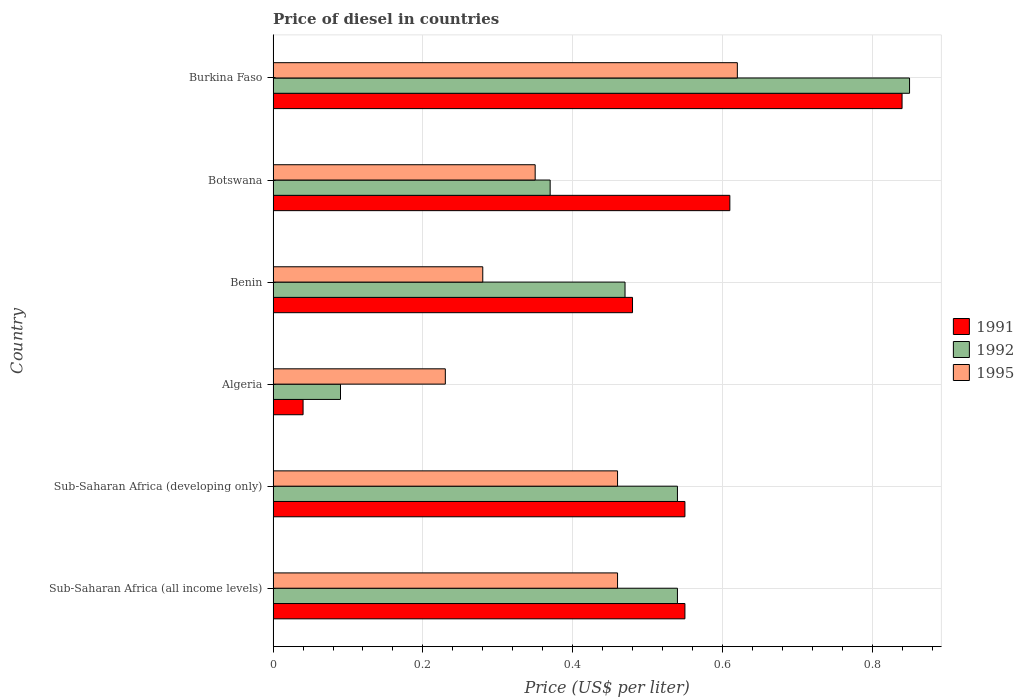How many groups of bars are there?
Your answer should be compact. 6. How many bars are there on the 6th tick from the top?
Your response must be concise. 3. How many bars are there on the 3rd tick from the bottom?
Your response must be concise. 3. What is the label of the 6th group of bars from the top?
Your answer should be compact. Sub-Saharan Africa (all income levels). In how many cases, is the number of bars for a given country not equal to the number of legend labels?
Ensure brevity in your answer.  0. What is the price of diesel in 1991 in Sub-Saharan Africa (all income levels)?
Offer a very short reply. 0.55. Across all countries, what is the maximum price of diesel in 1995?
Ensure brevity in your answer.  0.62. Across all countries, what is the minimum price of diesel in 1991?
Your answer should be very brief. 0.04. In which country was the price of diesel in 1991 maximum?
Provide a succinct answer. Burkina Faso. In which country was the price of diesel in 1991 minimum?
Provide a succinct answer. Algeria. What is the total price of diesel in 1992 in the graph?
Ensure brevity in your answer.  2.86. What is the difference between the price of diesel in 1991 in Benin and that in Botswana?
Your response must be concise. -0.13. What is the difference between the price of diesel in 1995 in Sub-Saharan Africa (all income levels) and the price of diesel in 1991 in Benin?
Your response must be concise. -0.02. What is the average price of diesel in 1995 per country?
Make the answer very short. 0.4. What is the difference between the price of diesel in 1995 and price of diesel in 1992 in Sub-Saharan Africa (all income levels)?
Offer a terse response. -0.08. What is the ratio of the price of diesel in 1991 in Burkina Faso to that in Sub-Saharan Africa (developing only)?
Ensure brevity in your answer.  1.53. Is the difference between the price of diesel in 1995 in Algeria and Botswana greater than the difference between the price of diesel in 1992 in Algeria and Botswana?
Ensure brevity in your answer.  Yes. What is the difference between the highest and the second highest price of diesel in 1991?
Offer a terse response. 0.23. What is the difference between the highest and the lowest price of diesel in 1991?
Offer a terse response. 0.8. In how many countries, is the price of diesel in 1995 greater than the average price of diesel in 1995 taken over all countries?
Make the answer very short. 3. What does the 2nd bar from the top in Benin represents?
Your response must be concise. 1992. What does the 3rd bar from the bottom in Sub-Saharan Africa (all income levels) represents?
Make the answer very short. 1995. How many bars are there?
Offer a terse response. 18. How many countries are there in the graph?
Your response must be concise. 6. What is the difference between two consecutive major ticks on the X-axis?
Keep it short and to the point. 0.2. Does the graph contain any zero values?
Provide a short and direct response. No. How are the legend labels stacked?
Your answer should be compact. Vertical. What is the title of the graph?
Ensure brevity in your answer.  Price of diesel in countries. Does "1998" appear as one of the legend labels in the graph?
Provide a succinct answer. No. What is the label or title of the X-axis?
Provide a succinct answer. Price (US$ per liter). What is the Price (US$ per liter) in 1991 in Sub-Saharan Africa (all income levels)?
Your response must be concise. 0.55. What is the Price (US$ per liter) in 1992 in Sub-Saharan Africa (all income levels)?
Offer a terse response. 0.54. What is the Price (US$ per liter) in 1995 in Sub-Saharan Africa (all income levels)?
Keep it short and to the point. 0.46. What is the Price (US$ per liter) in 1991 in Sub-Saharan Africa (developing only)?
Make the answer very short. 0.55. What is the Price (US$ per liter) of 1992 in Sub-Saharan Africa (developing only)?
Provide a succinct answer. 0.54. What is the Price (US$ per liter) in 1995 in Sub-Saharan Africa (developing only)?
Make the answer very short. 0.46. What is the Price (US$ per liter) of 1992 in Algeria?
Offer a terse response. 0.09. What is the Price (US$ per liter) in 1995 in Algeria?
Provide a short and direct response. 0.23. What is the Price (US$ per liter) in 1991 in Benin?
Offer a very short reply. 0.48. What is the Price (US$ per liter) of 1992 in Benin?
Your response must be concise. 0.47. What is the Price (US$ per liter) of 1995 in Benin?
Offer a very short reply. 0.28. What is the Price (US$ per liter) in 1991 in Botswana?
Provide a succinct answer. 0.61. What is the Price (US$ per liter) of 1992 in Botswana?
Provide a short and direct response. 0.37. What is the Price (US$ per liter) of 1991 in Burkina Faso?
Offer a terse response. 0.84. What is the Price (US$ per liter) in 1995 in Burkina Faso?
Give a very brief answer. 0.62. Across all countries, what is the maximum Price (US$ per liter) of 1991?
Offer a terse response. 0.84. Across all countries, what is the maximum Price (US$ per liter) in 1992?
Keep it short and to the point. 0.85. Across all countries, what is the maximum Price (US$ per liter) in 1995?
Keep it short and to the point. 0.62. Across all countries, what is the minimum Price (US$ per liter) in 1992?
Give a very brief answer. 0.09. Across all countries, what is the minimum Price (US$ per liter) of 1995?
Ensure brevity in your answer.  0.23. What is the total Price (US$ per liter) in 1991 in the graph?
Keep it short and to the point. 3.07. What is the total Price (US$ per liter) of 1992 in the graph?
Provide a succinct answer. 2.86. What is the difference between the Price (US$ per liter) of 1991 in Sub-Saharan Africa (all income levels) and that in Sub-Saharan Africa (developing only)?
Your answer should be compact. 0. What is the difference between the Price (US$ per liter) of 1995 in Sub-Saharan Africa (all income levels) and that in Sub-Saharan Africa (developing only)?
Give a very brief answer. 0. What is the difference between the Price (US$ per liter) of 1991 in Sub-Saharan Africa (all income levels) and that in Algeria?
Provide a short and direct response. 0.51. What is the difference between the Price (US$ per liter) in 1992 in Sub-Saharan Africa (all income levels) and that in Algeria?
Give a very brief answer. 0.45. What is the difference between the Price (US$ per liter) in 1995 in Sub-Saharan Africa (all income levels) and that in Algeria?
Your answer should be very brief. 0.23. What is the difference between the Price (US$ per liter) of 1991 in Sub-Saharan Africa (all income levels) and that in Benin?
Your answer should be compact. 0.07. What is the difference between the Price (US$ per liter) of 1992 in Sub-Saharan Africa (all income levels) and that in Benin?
Offer a very short reply. 0.07. What is the difference between the Price (US$ per liter) in 1995 in Sub-Saharan Africa (all income levels) and that in Benin?
Offer a very short reply. 0.18. What is the difference between the Price (US$ per liter) of 1991 in Sub-Saharan Africa (all income levels) and that in Botswana?
Your answer should be compact. -0.06. What is the difference between the Price (US$ per liter) of 1992 in Sub-Saharan Africa (all income levels) and that in Botswana?
Your answer should be compact. 0.17. What is the difference between the Price (US$ per liter) of 1995 in Sub-Saharan Africa (all income levels) and that in Botswana?
Ensure brevity in your answer.  0.11. What is the difference between the Price (US$ per liter) of 1991 in Sub-Saharan Africa (all income levels) and that in Burkina Faso?
Offer a terse response. -0.29. What is the difference between the Price (US$ per liter) in 1992 in Sub-Saharan Africa (all income levels) and that in Burkina Faso?
Your response must be concise. -0.31. What is the difference between the Price (US$ per liter) of 1995 in Sub-Saharan Africa (all income levels) and that in Burkina Faso?
Offer a very short reply. -0.16. What is the difference between the Price (US$ per liter) of 1991 in Sub-Saharan Africa (developing only) and that in Algeria?
Give a very brief answer. 0.51. What is the difference between the Price (US$ per liter) of 1992 in Sub-Saharan Africa (developing only) and that in Algeria?
Provide a succinct answer. 0.45. What is the difference between the Price (US$ per liter) in 1995 in Sub-Saharan Africa (developing only) and that in Algeria?
Offer a very short reply. 0.23. What is the difference between the Price (US$ per liter) of 1991 in Sub-Saharan Africa (developing only) and that in Benin?
Offer a terse response. 0.07. What is the difference between the Price (US$ per liter) of 1992 in Sub-Saharan Africa (developing only) and that in Benin?
Keep it short and to the point. 0.07. What is the difference between the Price (US$ per liter) in 1995 in Sub-Saharan Africa (developing only) and that in Benin?
Provide a succinct answer. 0.18. What is the difference between the Price (US$ per liter) in 1991 in Sub-Saharan Africa (developing only) and that in Botswana?
Your response must be concise. -0.06. What is the difference between the Price (US$ per liter) in 1992 in Sub-Saharan Africa (developing only) and that in Botswana?
Offer a very short reply. 0.17. What is the difference between the Price (US$ per liter) in 1995 in Sub-Saharan Africa (developing only) and that in Botswana?
Give a very brief answer. 0.11. What is the difference between the Price (US$ per liter) of 1991 in Sub-Saharan Africa (developing only) and that in Burkina Faso?
Keep it short and to the point. -0.29. What is the difference between the Price (US$ per liter) in 1992 in Sub-Saharan Africa (developing only) and that in Burkina Faso?
Your answer should be very brief. -0.31. What is the difference between the Price (US$ per liter) of 1995 in Sub-Saharan Africa (developing only) and that in Burkina Faso?
Offer a very short reply. -0.16. What is the difference between the Price (US$ per liter) of 1991 in Algeria and that in Benin?
Your response must be concise. -0.44. What is the difference between the Price (US$ per liter) of 1992 in Algeria and that in Benin?
Your answer should be compact. -0.38. What is the difference between the Price (US$ per liter) of 1991 in Algeria and that in Botswana?
Keep it short and to the point. -0.57. What is the difference between the Price (US$ per liter) in 1992 in Algeria and that in Botswana?
Provide a short and direct response. -0.28. What is the difference between the Price (US$ per liter) in 1995 in Algeria and that in Botswana?
Your answer should be compact. -0.12. What is the difference between the Price (US$ per liter) of 1992 in Algeria and that in Burkina Faso?
Make the answer very short. -0.76. What is the difference between the Price (US$ per liter) of 1995 in Algeria and that in Burkina Faso?
Ensure brevity in your answer.  -0.39. What is the difference between the Price (US$ per liter) of 1991 in Benin and that in Botswana?
Give a very brief answer. -0.13. What is the difference between the Price (US$ per liter) in 1995 in Benin and that in Botswana?
Keep it short and to the point. -0.07. What is the difference between the Price (US$ per liter) of 1991 in Benin and that in Burkina Faso?
Give a very brief answer. -0.36. What is the difference between the Price (US$ per liter) of 1992 in Benin and that in Burkina Faso?
Your response must be concise. -0.38. What is the difference between the Price (US$ per liter) of 1995 in Benin and that in Burkina Faso?
Your answer should be very brief. -0.34. What is the difference between the Price (US$ per liter) of 1991 in Botswana and that in Burkina Faso?
Provide a short and direct response. -0.23. What is the difference between the Price (US$ per liter) in 1992 in Botswana and that in Burkina Faso?
Ensure brevity in your answer.  -0.48. What is the difference between the Price (US$ per liter) of 1995 in Botswana and that in Burkina Faso?
Give a very brief answer. -0.27. What is the difference between the Price (US$ per liter) in 1991 in Sub-Saharan Africa (all income levels) and the Price (US$ per liter) in 1995 in Sub-Saharan Africa (developing only)?
Provide a succinct answer. 0.09. What is the difference between the Price (US$ per liter) of 1992 in Sub-Saharan Africa (all income levels) and the Price (US$ per liter) of 1995 in Sub-Saharan Africa (developing only)?
Your answer should be compact. 0.08. What is the difference between the Price (US$ per liter) in 1991 in Sub-Saharan Africa (all income levels) and the Price (US$ per liter) in 1992 in Algeria?
Make the answer very short. 0.46. What is the difference between the Price (US$ per liter) in 1991 in Sub-Saharan Africa (all income levels) and the Price (US$ per liter) in 1995 in Algeria?
Offer a terse response. 0.32. What is the difference between the Price (US$ per liter) of 1992 in Sub-Saharan Africa (all income levels) and the Price (US$ per liter) of 1995 in Algeria?
Provide a succinct answer. 0.31. What is the difference between the Price (US$ per liter) in 1991 in Sub-Saharan Africa (all income levels) and the Price (US$ per liter) in 1995 in Benin?
Offer a terse response. 0.27. What is the difference between the Price (US$ per liter) of 1992 in Sub-Saharan Africa (all income levels) and the Price (US$ per liter) of 1995 in Benin?
Your answer should be very brief. 0.26. What is the difference between the Price (US$ per liter) in 1991 in Sub-Saharan Africa (all income levels) and the Price (US$ per liter) in 1992 in Botswana?
Offer a terse response. 0.18. What is the difference between the Price (US$ per liter) in 1992 in Sub-Saharan Africa (all income levels) and the Price (US$ per liter) in 1995 in Botswana?
Ensure brevity in your answer.  0.19. What is the difference between the Price (US$ per liter) in 1991 in Sub-Saharan Africa (all income levels) and the Price (US$ per liter) in 1992 in Burkina Faso?
Your answer should be compact. -0.3. What is the difference between the Price (US$ per liter) in 1991 in Sub-Saharan Africa (all income levels) and the Price (US$ per liter) in 1995 in Burkina Faso?
Your response must be concise. -0.07. What is the difference between the Price (US$ per liter) in 1992 in Sub-Saharan Africa (all income levels) and the Price (US$ per liter) in 1995 in Burkina Faso?
Give a very brief answer. -0.08. What is the difference between the Price (US$ per liter) of 1991 in Sub-Saharan Africa (developing only) and the Price (US$ per liter) of 1992 in Algeria?
Your answer should be compact. 0.46. What is the difference between the Price (US$ per liter) in 1991 in Sub-Saharan Africa (developing only) and the Price (US$ per liter) in 1995 in Algeria?
Your answer should be very brief. 0.32. What is the difference between the Price (US$ per liter) in 1992 in Sub-Saharan Africa (developing only) and the Price (US$ per liter) in 1995 in Algeria?
Offer a very short reply. 0.31. What is the difference between the Price (US$ per liter) of 1991 in Sub-Saharan Africa (developing only) and the Price (US$ per liter) of 1995 in Benin?
Offer a very short reply. 0.27. What is the difference between the Price (US$ per liter) of 1992 in Sub-Saharan Africa (developing only) and the Price (US$ per liter) of 1995 in Benin?
Give a very brief answer. 0.26. What is the difference between the Price (US$ per liter) of 1991 in Sub-Saharan Africa (developing only) and the Price (US$ per liter) of 1992 in Botswana?
Provide a succinct answer. 0.18. What is the difference between the Price (US$ per liter) in 1992 in Sub-Saharan Africa (developing only) and the Price (US$ per liter) in 1995 in Botswana?
Keep it short and to the point. 0.19. What is the difference between the Price (US$ per liter) in 1991 in Sub-Saharan Africa (developing only) and the Price (US$ per liter) in 1995 in Burkina Faso?
Your answer should be very brief. -0.07. What is the difference between the Price (US$ per liter) in 1992 in Sub-Saharan Africa (developing only) and the Price (US$ per liter) in 1995 in Burkina Faso?
Your response must be concise. -0.08. What is the difference between the Price (US$ per liter) of 1991 in Algeria and the Price (US$ per liter) of 1992 in Benin?
Your answer should be very brief. -0.43. What is the difference between the Price (US$ per liter) in 1991 in Algeria and the Price (US$ per liter) in 1995 in Benin?
Ensure brevity in your answer.  -0.24. What is the difference between the Price (US$ per liter) in 1992 in Algeria and the Price (US$ per liter) in 1995 in Benin?
Your response must be concise. -0.19. What is the difference between the Price (US$ per liter) in 1991 in Algeria and the Price (US$ per liter) in 1992 in Botswana?
Provide a short and direct response. -0.33. What is the difference between the Price (US$ per liter) of 1991 in Algeria and the Price (US$ per liter) of 1995 in Botswana?
Keep it short and to the point. -0.31. What is the difference between the Price (US$ per liter) of 1992 in Algeria and the Price (US$ per liter) of 1995 in Botswana?
Provide a succinct answer. -0.26. What is the difference between the Price (US$ per liter) in 1991 in Algeria and the Price (US$ per liter) in 1992 in Burkina Faso?
Provide a short and direct response. -0.81. What is the difference between the Price (US$ per liter) of 1991 in Algeria and the Price (US$ per liter) of 1995 in Burkina Faso?
Make the answer very short. -0.58. What is the difference between the Price (US$ per liter) of 1992 in Algeria and the Price (US$ per liter) of 1995 in Burkina Faso?
Make the answer very short. -0.53. What is the difference between the Price (US$ per liter) in 1991 in Benin and the Price (US$ per liter) in 1992 in Botswana?
Give a very brief answer. 0.11. What is the difference between the Price (US$ per liter) in 1991 in Benin and the Price (US$ per liter) in 1995 in Botswana?
Your response must be concise. 0.13. What is the difference between the Price (US$ per liter) of 1992 in Benin and the Price (US$ per liter) of 1995 in Botswana?
Make the answer very short. 0.12. What is the difference between the Price (US$ per liter) in 1991 in Benin and the Price (US$ per liter) in 1992 in Burkina Faso?
Give a very brief answer. -0.37. What is the difference between the Price (US$ per liter) of 1991 in Benin and the Price (US$ per liter) of 1995 in Burkina Faso?
Make the answer very short. -0.14. What is the difference between the Price (US$ per liter) in 1991 in Botswana and the Price (US$ per liter) in 1992 in Burkina Faso?
Your answer should be compact. -0.24. What is the difference between the Price (US$ per liter) of 1991 in Botswana and the Price (US$ per liter) of 1995 in Burkina Faso?
Offer a terse response. -0.01. What is the average Price (US$ per liter) of 1991 per country?
Your response must be concise. 0.51. What is the average Price (US$ per liter) in 1992 per country?
Keep it short and to the point. 0.48. What is the average Price (US$ per liter) of 1995 per country?
Keep it short and to the point. 0.4. What is the difference between the Price (US$ per liter) of 1991 and Price (US$ per liter) of 1992 in Sub-Saharan Africa (all income levels)?
Offer a very short reply. 0.01. What is the difference between the Price (US$ per liter) of 1991 and Price (US$ per liter) of 1995 in Sub-Saharan Africa (all income levels)?
Give a very brief answer. 0.09. What is the difference between the Price (US$ per liter) of 1992 and Price (US$ per liter) of 1995 in Sub-Saharan Africa (all income levels)?
Your response must be concise. 0.08. What is the difference between the Price (US$ per liter) in 1991 and Price (US$ per liter) in 1992 in Sub-Saharan Africa (developing only)?
Your answer should be compact. 0.01. What is the difference between the Price (US$ per liter) of 1991 and Price (US$ per liter) of 1995 in Sub-Saharan Africa (developing only)?
Your response must be concise. 0.09. What is the difference between the Price (US$ per liter) in 1992 and Price (US$ per liter) in 1995 in Sub-Saharan Africa (developing only)?
Your response must be concise. 0.08. What is the difference between the Price (US$ per liter) of 1991 and Price (US$ per liter) of 1992 in Algeria?
Make the answer very short. -0.05. What is the difference between the Price (US$ per liter) of 1991 and Price (US$ per liter) of 1995 in Algeria?
Give a very brief answer. -0.19. What is the difference between the Price (US$ per liter) in 1992 and Price (US$ per liter) in 1995 in Algeria?
Your answer should be very brief. -0.14. What is the difference between the Price (US$ per liter) of 1992 and Price (US$ per liter) of 1995 in Benin?
Provide a succinct answer. 0.19. What is the difference between the Price (US$ per liter) in 1991 and Price (US$ per liter) in 1992 in Botswana?
Provide a short and direct response. 0.24. What is the difference between the Price (US$ per liter) of 1991 and Price (US$ per liter) of 1995 in Botswana?
Make the answer very short. 0.26. What is the difference between the Price (US$ per liter) of 1992 and Price (US$ per liter) of 1995 in Botswana?
Provide a short and direct response. 0.02. What is the difference between the Price (US$ per liter) of 1991 and Price (US$ per liter) of 1992 in Burkina Faso?
Your answer should be very brief. -0.01. What is the difference between the Price (US$ per liter) of 1991 and Price (US$ per liter) of 1995 in Burkina Faso?
Give a very brief answer. 0.22. What is the difference between the Price (US$ per liter) of 1992 and Price (US$ per liter) of 1995 in Burkina Faso?
Provide a short and direct response. 0.23. What is the ratio of the Price (US$ per liter) in 1991 in Sub-Saharan Africa (all income levels) to that in Sub-Saharan Africa (developing only)?
Provide a short and direct response. 1. What is the ratio of the Price (US$ per liter) in 1992 in Sub-Saharan Africa (all income levels) to that in Sub-Saharan Africa (developing only)?
Your answer should be compact. 1. What is the ratio of the Price (US$ per liter) of 1995 in Sub-Saharan Africa (all income levels) to that in Sub-Saharan Africa (developing only)?
Ensure brevity in your answer.  1. What is the ratio of the Price (US$ per liter) of 1991 in Sub-Saharan Africa (all income levels) to that in Algeria?
Provide a short and direct response. 13.75. What is the ratio of the Price (US$ per liter) of 1992 in Sub-Saharan Africa (all income levels) to that in Algeria?
Provide a succinct answer. 6. What is the ratio of the Price (US$ per liter) in 1995 in Sub-Saharan Africa (all income levels) to that in Algeria?
Give a very brief answer. 2. What is the ratio of the Price (US$ per liter) of 1991 in Sub-Saharan Africa (all income levels) to that in Benin?
Keep it short and to the point. 1.15. What is the ratio of the Price (US$ per liter) of 1992 in Sub-Saharan Africa (all income levels) to that in Benin?
Your answer should be very brief. 1.15. What is the ratio of the Price (US$ per liter) in 1995 in Sub-Saharan Africa (all income levels) to that in Benin?
Offer a terse response. 1.64. What is the ratio of the Price (US$ per liter) of 1991 in Sub-Saharan Africa (all income levels) to that in Botswana?
Provide a succinct answer. 0.9. What is the ratio of the Price (US$ per liter) of 1992 in Sub-Saharan Africa (all income levels) to that in Botswana?
Provide a short and direct response. 1.46. What is the ratio of the Price (US$ per liter) of 1995 in Sub-Saharan Africa (all income levels) to that in Botswana?
Your answer should be compact. 1.31. What is the ratio of the Price (US$ per liter) of 1991 in Sub-Saharan Africa (all income levels) to that in Burkina Faso?
Your answer should be very brief. 0.65. What is the ratio of the Price (US$ per liter) of 1992 in Sub-Saharan Africa (all income levels) to that in Burkina Faso?
Make the answer very short. 0.64. What is the ratio of the Price (US$ per liter) in 1995 in Sub-Saharan Africa (all income levels) to that in Burkina Faso?
Offer a terse response. 0.74. What is the ratio of the Price (US$ per liter) of 1991 in Sub-Saharan Africa (developing only) to that in Algeria?
Keep it short and to the point. 13.75. What is the ratio of the Price (US$ per liter) in 1992 in Sub-Saharan Africa (developing only) to that in Algeria?
Ensure brevity in your answer.  6. What is the ratio of the Price (US$ per liter) of 1991 in Sub-Saharan Africa (developing only) to that in Benin?
Provide a succinct answer. 1.15. What is the ratio of the Price (US$ per liter) in 1992 in Sub-Saharan Africa (developing only) to that in Benin?
Make the answer very short. 1.15. What is the ratio of the Price (US$ per liter) in 1995 in Sub-Saharan Africa (developing only) to that in Benin?
Make the answer very short. 1.64. What is the ratio of the Price (US$ per liter) of 1991 in Sub-Saharan Africa (developing only) to that in Botswana?
Provide a short and direct response. 0.9. What is the ratio of the Price (US$ per liter) in 1992 in Sub-Saharan Africa (developing only) to that in Botswana?
Provide a succinct answer. 1.46. What is the ratio of the Price (US$ per liter) in 1995 in Sub-Saharan Africa (developing only) to that in Botswana?
Provide a succinct answer. 1.31. What is the ratio of the Price (US$ per liter) of 1991 in Sub-Saharan Africa (developing only) to that in Burkina Faso?
Offer a terse response. 0.65. What is the ratio of the Price (US$ per liter) in 1992 in Sub-Saharan Africa (developing only) to that in Burkina Faso?
Offer a terse response. 0.64. What is the ratio of the Price (US$ per liter) of 1995 in Sub-Saharan Africa (developing only) to that in Burkina Faso?
Provide a succinct answer. 0.74. What is the ratio of the Price (US$ per liter) of 1991 in Algeria to that in Benin?
Your response must be concise. 0.08. What is the ratio of the Price (US$ per liter) in 1992 in Algeria to that in Benin?
Offer a terse response. 0.19. What is the ratio of the Price (US$ per liter) in 1995 in Algeria to that in Benin?
Offer a terse response. 0.82. What is the ratio of the Price (US$ per liter) in 1991 in Algeria to that in Botswana?
Your response must be concise. 0.07. What is the ratio of the Price (US$ per liter) of 1992 in Algeria to that in Botswana?
Give a very brief answer. 0.24. What is the ratio of the Price (US$ per liter) in 1995 in Algeria to that in Botswana?
Keep it short and to the point. 0.66. What is the ratio of the Price (US$ per liter) in 1991 in Algeria to that in Burkina Faso?
Give a very brief answer. 0.05. What is the ratio of the Price (US$ per liter) of 1992 in Algeria to that in Burkina Faso?
Your answer should be compact. 0.11. What is the ratio of the Price (US$ per liter) of 1995 in Algeria to that in Burkina Faso?
Make the answer very short. 0.37. What is the ratio of the Price (US$ per liter) in 1991 in Benin to that in Botswana?
Provide a short and direct response. 0.79. What is the ratio of the Price (US$ per liter) of 1992 in Benin to that in Botswana?
Keep it short and to the point. 1.27. What is the ratio of the Price (US$ per liter) of 1991 in Benin to that in Burkina Faso?
Keep it short and to the point. 0.57. What is the ratio of the Price (US$ per liter) in 1992 in Benin to that in Burkina Faso?
Keep it short and to the point. 0.55. What is the ratio of the Price (US$ per liter) in 1995 in Benin to that in Burkina Faso?
Ensure brevity in your answer.  0.45. What is the ratio of the Price (US$ per liter) of 1991 in Botswana to that in Burkina Faso?
Offer a terse response. 0.73. What is the ratio of the Price (US$ per liter) in 1992 in Botswana to that in Burkina Faso?
Your answer should be very brief. 0.44. What is the ratio of the Price (US$ per liter) of 1995 in Botswana to that in Burkina Faso?
Make the answer very short. 0.56. What is the difference between the highest and the second highest Price (US$ per liter) in 1991?
Provide a succinct answer. 0.23. What is the difference between the highest and the second highest Price (US$ per liter) in 1992?
Ensure brevity in your answer.  0.31. What is the difference between the highest and the second highest Price (US$ per liter) in 1995?
Your answer should be compact. 0.16. What is the difference between the highest and the lowest Price (US$ per liter) of 1992?
Give a very brief answer. 0.76. What is the difference between the highest and the lowest Price (US$ per liter) of 1995?
Your answer should be very brief. 0.39. 